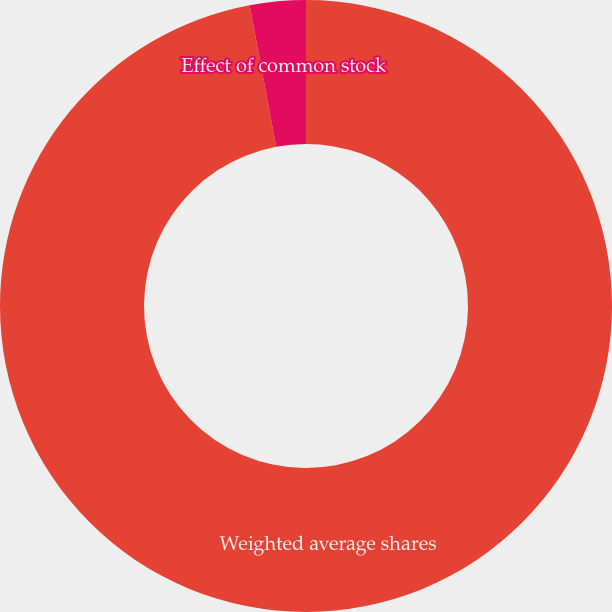Convert chart. <chart><loc_0><loc_0><loc_500><loc_500><pie_chart><fcel>Weighted average shares<fcel>Effect of common stock<nl><fcel>97.05%<fcel>2.95%<nl></chart> 